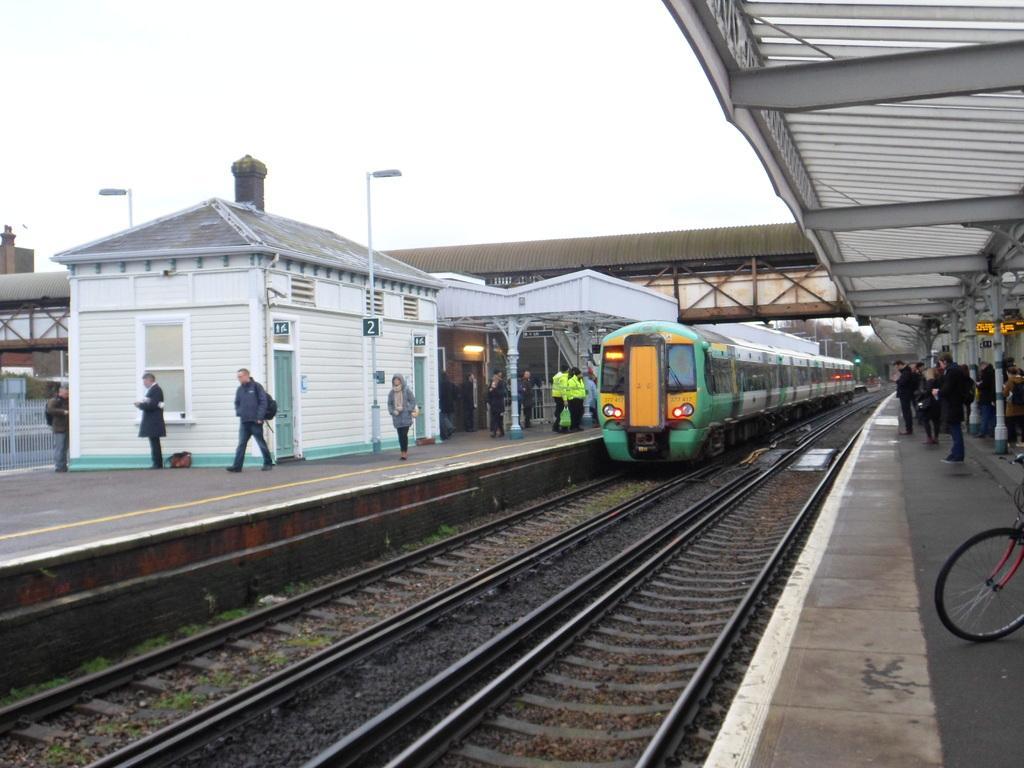Describe this image in one or two sentences. In this picture we can see a train on a railway track, some people on the platform, sheds, poles, bridge, fence, trees, some objects and in the background we can see the sky. 